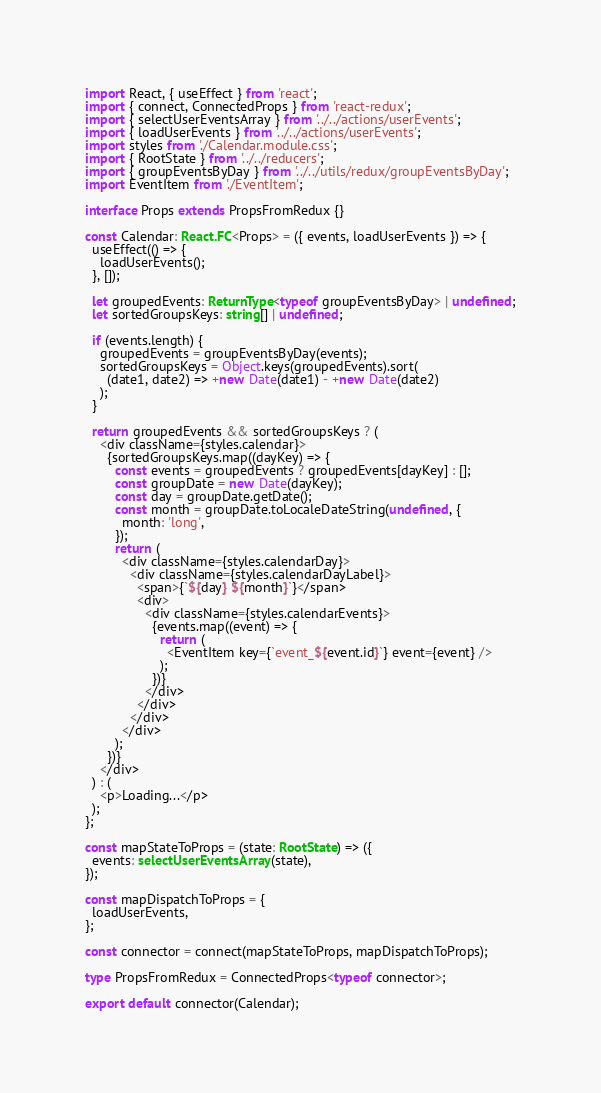Convert code to text. <code><loc_0><loc_0><loc_500><loc_500><_TypeScript_>import React, { useEffect } from 'react';
import { connect, ConnectedProps } from 'react-redux';
import { selectUserEventsArray } from '../../actions/userEvents';
import { loadUserEvents } from '../../actions/userEvents';
import styles from './Calendar.module.css';
import { RootState } from '../../reducers';
import { groupEventsByDay } from '../../utils/redux/groupEventsByDay';
import EventItem from './EventItem';

interface Props extends PropsFromRedux {}

const Calendar: React.FC<Props> = ({ events, loadUserEvents }) => {
  useEffect(() => {
    loadUserEvents();
  }, []);

  let groupedEvents: ReturnType<typeof groupEventsByDay> | undefined;
  let sortedGroupsKeys: string[] | undefined;

  if (events.length) {
    groupedEvents = groupEventsByDay(events);
    sortedGroupsKeys = Object.keys(groupedEvents).sort(
      (date1, date2) => +new Date(date1) - +new Date(date2)
    );
  }

  return groupedEvents && sortedGroupsKeys ? (
    <div className={styles.calendar}>
      {sortedGroupsKeys.map((dayKey) => {
        const events = groupedEvents ? groupedEvents[dayKey] : [];
        const groupDate = new Date(dayKey);
        const day = groupDate.getDate();
        const month = groupDate.toLocaleDateString(undefined, {
          month: 'long',
        });
        return (
          <div className={styles.calendarDay}>
            <div className={styles.calendarDayLabel}>
              <span>{`${day} ${month}`}</span>
              <div>
                <div className={styles.calendarEvents}>
                  {events.map((event) => {
                    return (
                      <EventItem key={`event_${event.id}`} event={event} />
                    );
                  })}
                </div>
              </div>
            </div>
          </div>
        );
      })}
    </div>
  ) : (
    <p>Loading...</p>
  );
};

const mapStateToProps = (state: RootState) => ({
  events: selectUserEventsArray(state),
});

const mapDispatchToProps = {
  loadUserEvents,
};

const connector = connect(mapStateToProps, mapDispatchToProps);

type PropsFromRedux = ConnectedProps<typeof connector>;

export default connector(Calendar);
</code> 